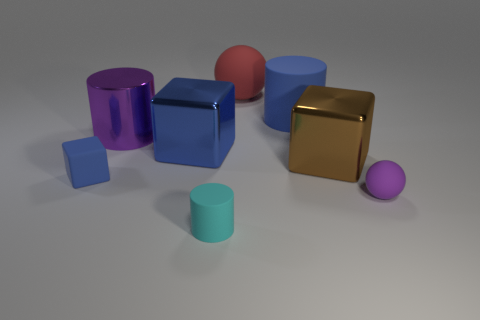There is a matte sphere behind the purple metallic thing; is there a large red thing that is behind it?
Your answer should be very brief. No. Is the number of red rubber spheres that are left of the large rubber ball the same as the number of small red cubes?
Ensure brevity in your answer.  Yes. What number of rubber cylinders are in front of the purple object that is behind the blue matte cube to the left of the purple metal thing?
Your answer should be compact. 1. Are there any rubber cylinders that have the same size as the red matte object?
Ensure brevity in your answer.  Yes. Is the number of things to the left of the small matte ball less than the number of blue shiny cubes?
Provide a succinct answer. No. What material is the blue cube right of the big cylinder in front of the cylinder that is right of the cyan cylinder?
Your answer should be very brief. Metal. Are there more red things that are to the left of the metal cylinder than big blue metal objects to the right of the small blue rubber cube?
Ensure brevity in your answer.  No. How many matte things are either purple balls or large blue things?
Offer a terse response. 2. The large object that is the same color as the small sphere is what shape?
Your response must be concise. Cylinder. There is a sphere behind the tiny blue matte block; what material is it?
Keep it short and to the point. Rubber. 